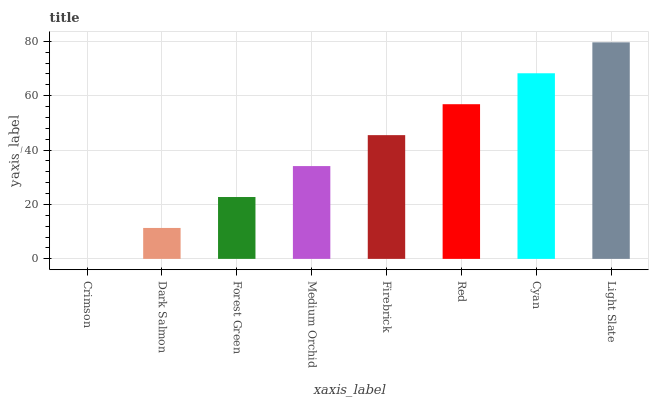Is Crimson the minimum?
Answer yes or no. Yes. Is Light Slate the maximum?
Answer yes or no. Yes. Is Dark Salmon the minimum?
Answer yes or no. No. Is Dark Salmon the maximum?
Answer yes or no. No. Is Dark Salmon greater than Crimson?
Answer yes or no. Yes. Is Crimson less than Dark Salmon?
Answer yes or no. Yes. Is Crimson greater than Dark Salmon?
Answer yes or no. No. Is Dark Salmon less than Crimson?
Answer yes or no. No. Is Firebrick the high median?
Answer yes or no. Yes. Is Medium Orchid the low median?
Answer yes or no. Yes. Is Dark Salmon the high median?
Answer yes or no. No. Is Firebrick the low median?
Answer yes or no. No. 